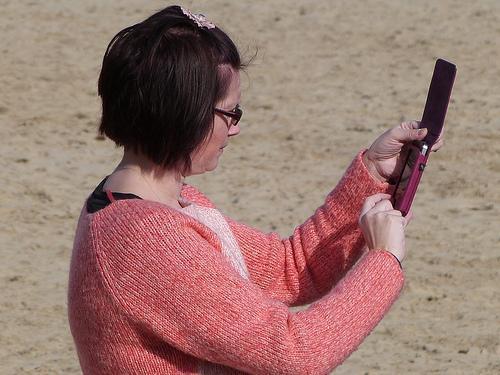How many women are there?
Give a very brief answer. 1. 